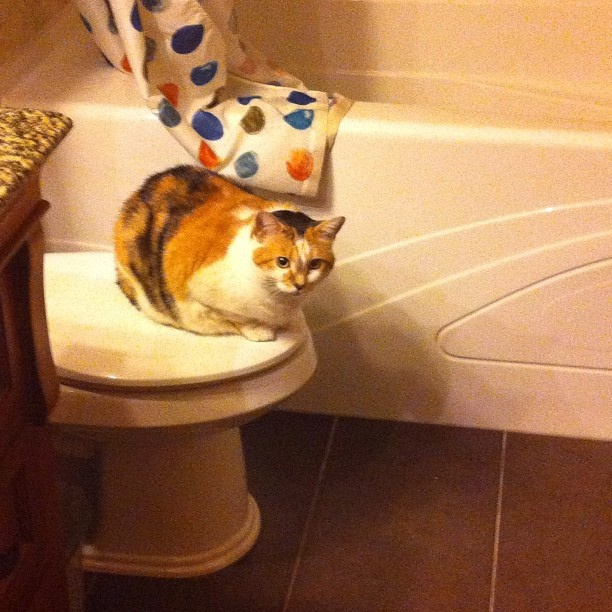Describe the objects in this image and their specific colors. I can see toilet in brown, maroon, and khaki tones and cat in brown, tan, khaki, and orange tones in this image. 